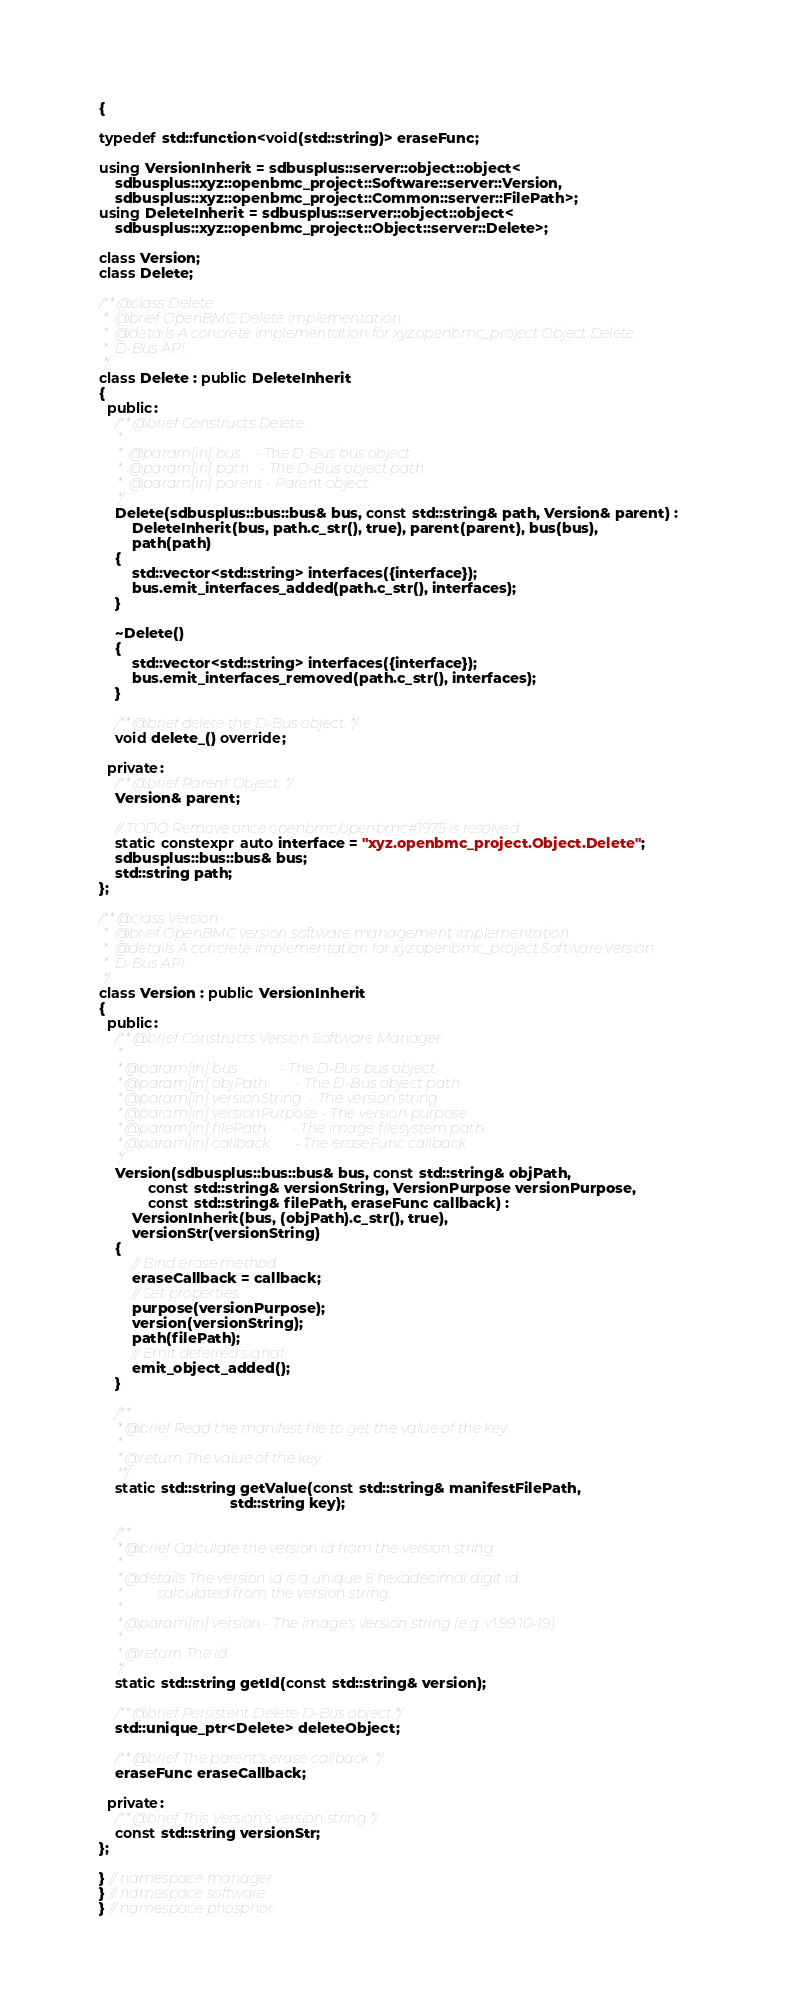Convert code to text. <code><loc_0><loc_0><loc_500><loc_500><_C++_>{

typedef std::function<void(std::string)> eraseFunc;

using VersionInherit = sdbusplus::server::object::object<
    sdbusplus::xyz::openbmc_project::Software::server::Version,
    sdbusplus::xyz::openbmc_project::Common::server::FilePath>;
using DeleteInherit = sdbusplus::server::object::object<
    sdbusplus::xyz::openbmc_project::Object::server::Delete>;

class Version;
class Delete;

/** @class Delete
 *  @brief OpenBMC Delete implementation.
 *  @details A concrete implementation for xyz.openbmc_project.Object.Delete
 *  D-Bus API.
 */
class Delete : public DeleteInherit
{
  public:
    /** @brief Constructs Delete.
     *
     *  @param[in] bus    - The D-Bus bus object
     *  @param[in] path   - The D-Bus object path
     *  @param[in] parent - Parent object.
     */
    Delete(sdbusplus::bus::bus& bus, const std::string& path, Version& parent) :
        DeleteInherit(bus, path.c_str(), true), parent(parent), bus(bus),
        path(path)
    {
        std::vector<std::string> interfaces({interface});
        bus.emit_interfaces_added(path.c_str(), interfaces);
    }

    ~Delete()
    {
        std::vector<std::string> interfaces({interface});
        bus.emit_interfaces_removed(path.c_str(), interfaces);
    }

    /** @brief delete the D-Bus object. */
    void delete_() override;

  private:
    /** @brief Parent Object. */
    Version& parent;

    // TODO Remove once openbmc/openbmc#1975 is resolved
    static constexpr auto interface = "xyz.openbmc_project.Object.Delete";
    sdbusplus::bus::bus& bus;
    std::string path;
};

/** @class Version
 *  @brief OpenBMC version software management implementation.
 *  @details A concrete implementation for xyz.openbmc_project.Software.Version
 *  D-Bus API.
 */
class Version : public VersionInherit
{
  public:
    /** @brief Constructs Version Software Manager
     *
     * @param[in] bus            - The D-Bus bus object
     * @param[in] objPath        - The D-Bus object path
     * @param[in] versionString  - The version string
     * @param[in] versionPurpose - The version purpose
     * @param[in] filePath       - The image filesystem path
     * @param[in] callback       - The eraseFunc callback
     */
    Version(sdbusplus::bus::bus& bus, const std::string& objPath,
            const std::string& versionString, VersionPurpose versionPurpose,
            const std::string& filePath, eraseFunc callback) :
        VersionInherit(bus, (objPath).c_str(), true),
        versionStr(versionString)
    {
        // Bind erase method
        eraseCallback = callback;
        // Set properties.
        purpose(versionPurpose);
        version(versionString);
        path(filePath);
        // Emit deferred signal.
        emit_object_added();
    }

    /**
     * @brief Read the manifest file to get the value of the key.
     *
     * @return The value of the key.
     **/
    static std::string getValue(const std::string& manifestFilePath,
                                std::string key);

    /**
     * @brief Calculate the version id from the version string.
     *
     * @details The version id is a unique 8 hexadecimal digit id
     *          calculated from the version string.
     *
     * @param[in] version - The image's version string (e.g. v1.99.10-19).
     *
     * @return The id.
     */
    static std::string getId(const std::string& version);

    /** @brief Persistent Delete D-Bus object */
    std::unique_ptr<Delete> deleteObject;

    /** @brief The parent's erase callback. */
    eraseFunc eraseCallback;

  private:
    /** @brief This Version's version string */
    const std::string versionStr;
};

} // namespace manager
} // namespace software
} // namespace phosphor
</code> 